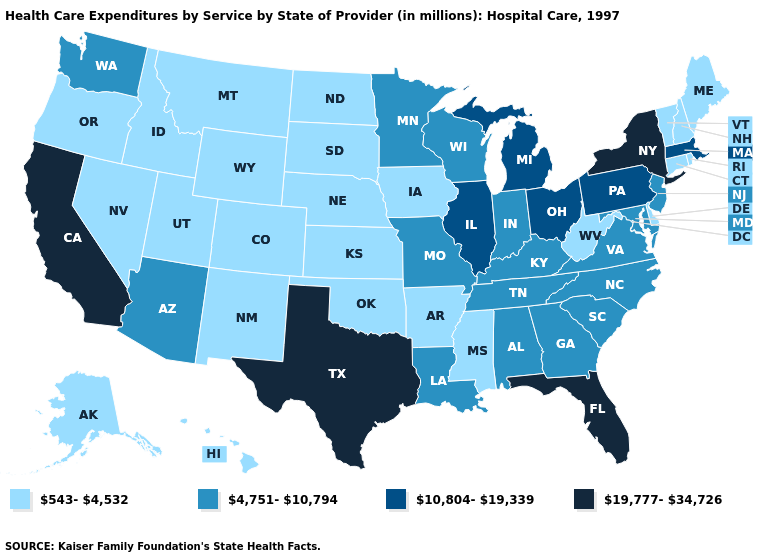Name the states that have a value in the range 10,804-19,339?
Write a very short answer. Illinois, Massachusetts, Michigan, Ohio, Pennsylvania. Name the states that have a value in the range 543-4,532?
Short answer required. Alaska, Arkansas, Colorado, Connecticut, Delaware, Hawaii, Idaho, Iowa, Kansas, Maine, Mississippi, Montana, Nebraska, Nevada, New Hampshire, New Mexico, North Dakota, Oklahoma, Oregon, Rhode Island, South Dakota, Utah, Vermont, West Virginia, Wyoming. What is the highest value in the West ?
Be succinct. 19,777-34,726. What is the value of Mississippi?
Be succinct. 543-4,532. What is the value of Nebraska?
Short answer required. 543-4,532. Does South Dakota have the highest value in the MidWest?
Keep it brief. No. Does Connecticut have a higher value than Louisiana?
Keep it brief. No. Among the states that border Massachusetts , which have the highest value?
Short answer required. New York. What is the value of Alaska?
Keep it brief. 543-4,532. Is the legend a continuous bar?
Answer briefly. No. Among the states that border Iowa , which have the highest value?
Short answer required. Illinois. Among the states that border Indiana , does Kentucky have the lowest value?
Write a very short answer. Yes. Is the legend a continuous bar?
Short answer required. No. Does New York have the highest value in the USA?
Answer briefly. Yes. What is the lowest value in the USA?
Quick response, please. 543-4,532. 